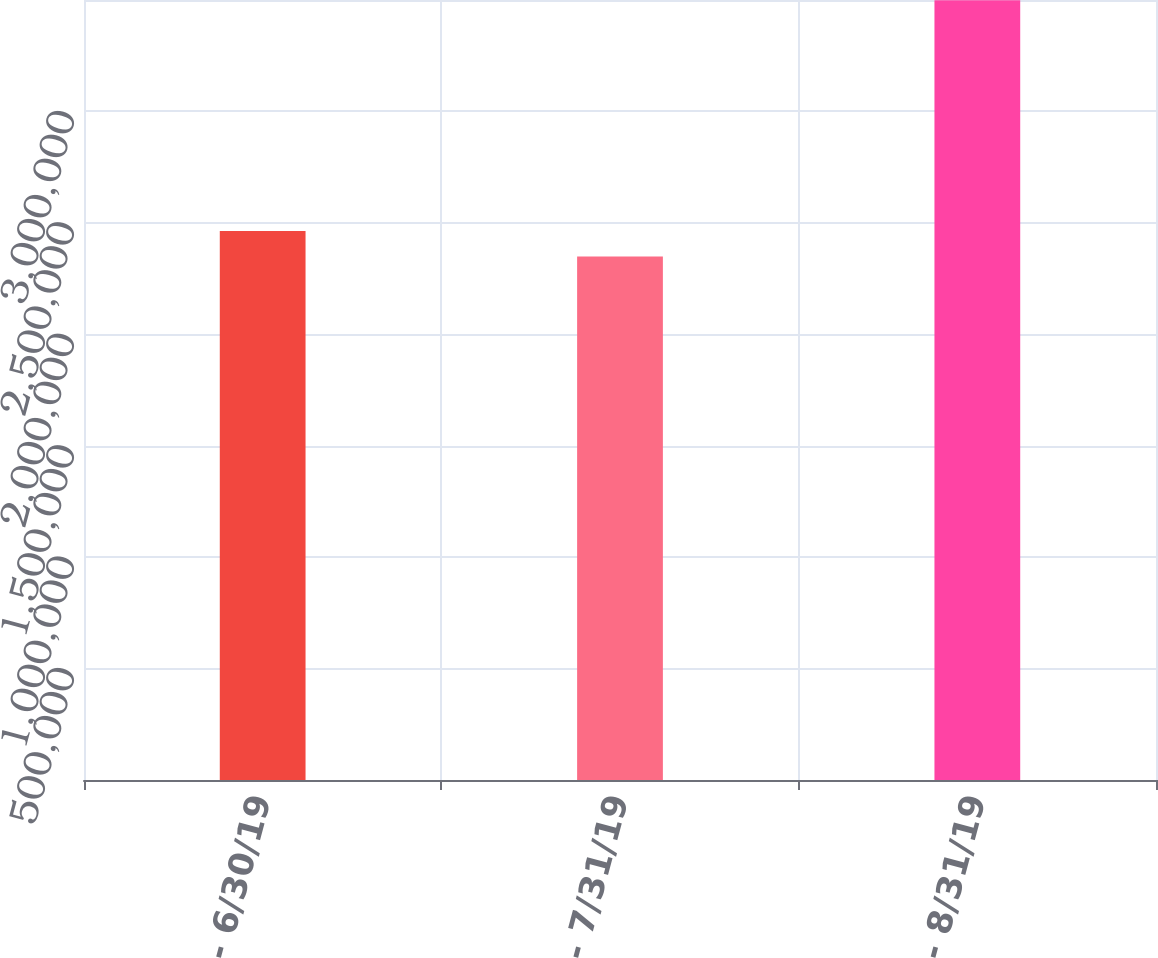<chart> <loc_0><loc_0><loc_500><loc_500><bar_chart><fcel>6/1/19 - 6/30/19<fcel>7/1/19 - 7/31/19<fcel>8/1/19 - 8/31/19<nl><fcel>2.46348e+06<fcel>2.34849e+06<fcel>3.4984e+06<nl></chart> 